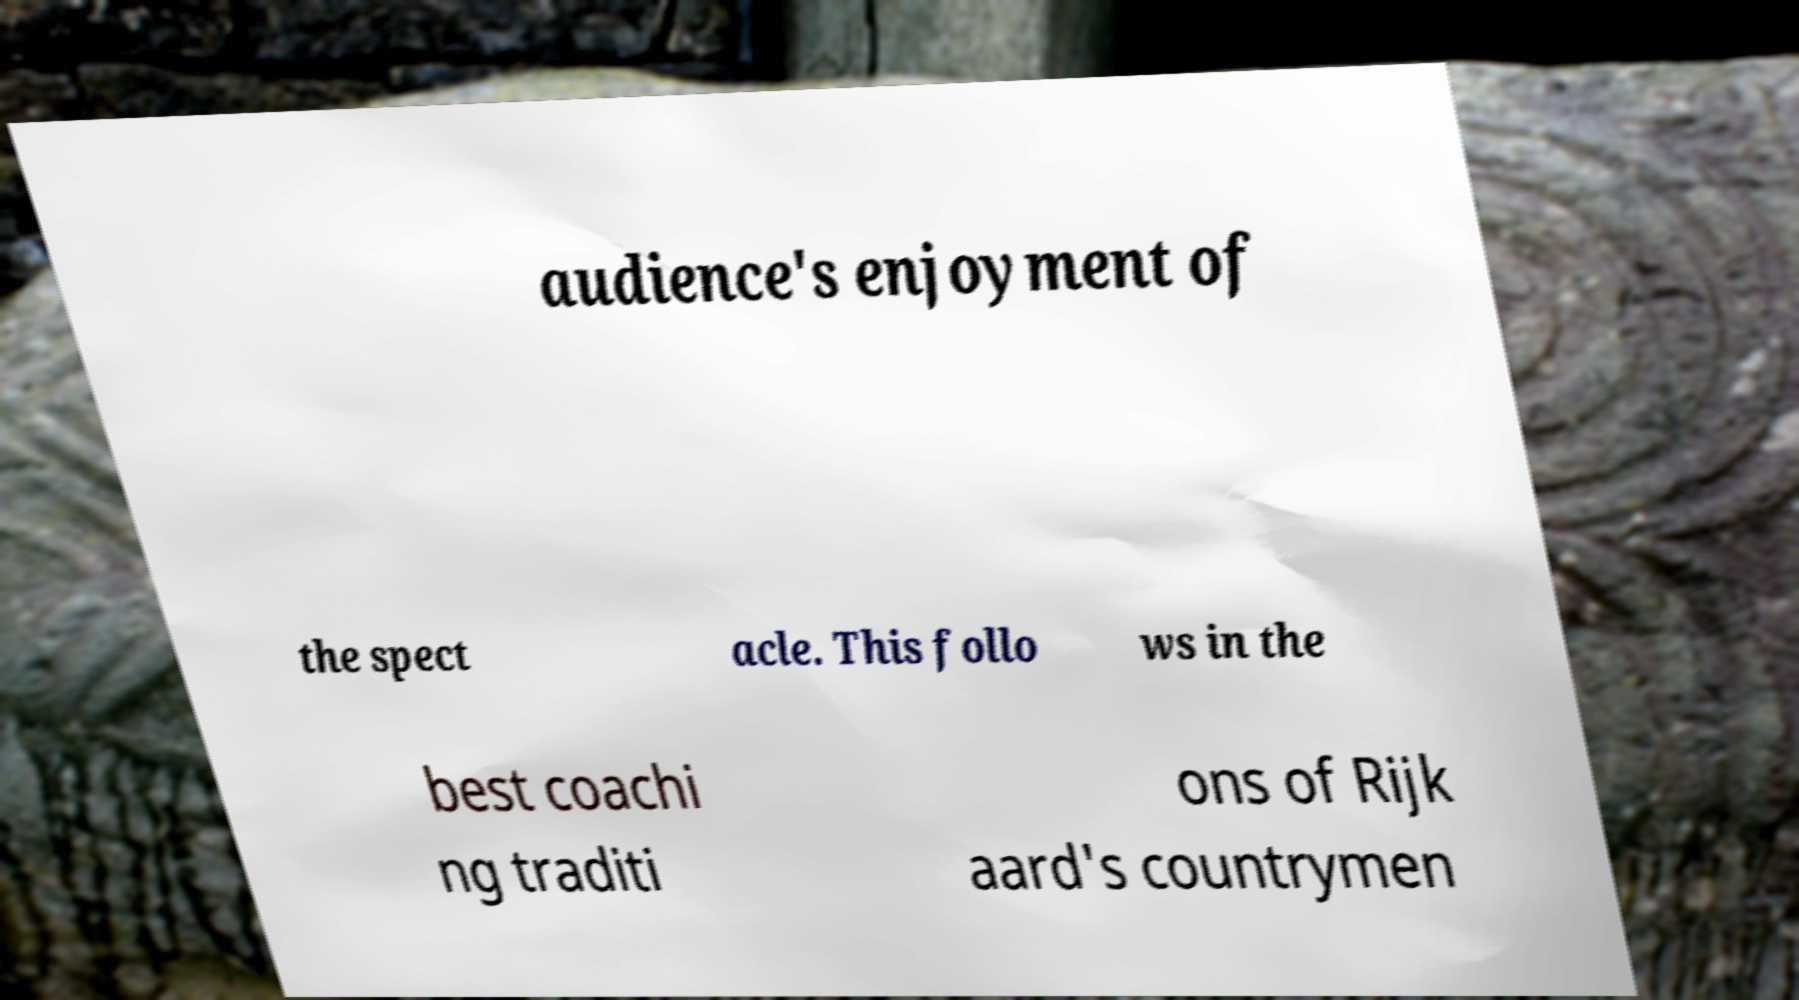Could you assist in decoding the text presented in this image and type it out clearly? audience's enjoyment of the spect acle. This follo ws in the best coachi ng traditi ons of Rijk aard's countrymen 